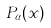Convert formula to latex. <formula><loc_0><loc_0><loc_500><loc_500>P _ { \alpha } ( x )</formula> 